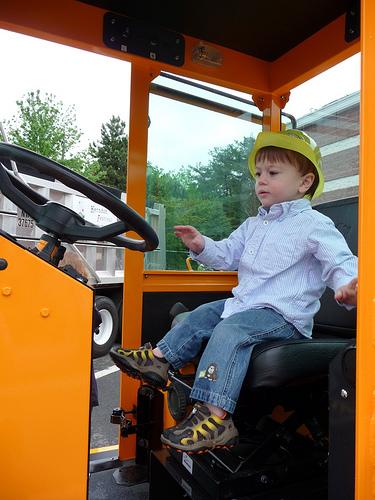What color is the boy's hat?
Answer briefly. Yellow. What kind of shoes is the boy wearing?
Write a very short answer. Sneakers. What is the boy riding?
Keep it brief. Train. 